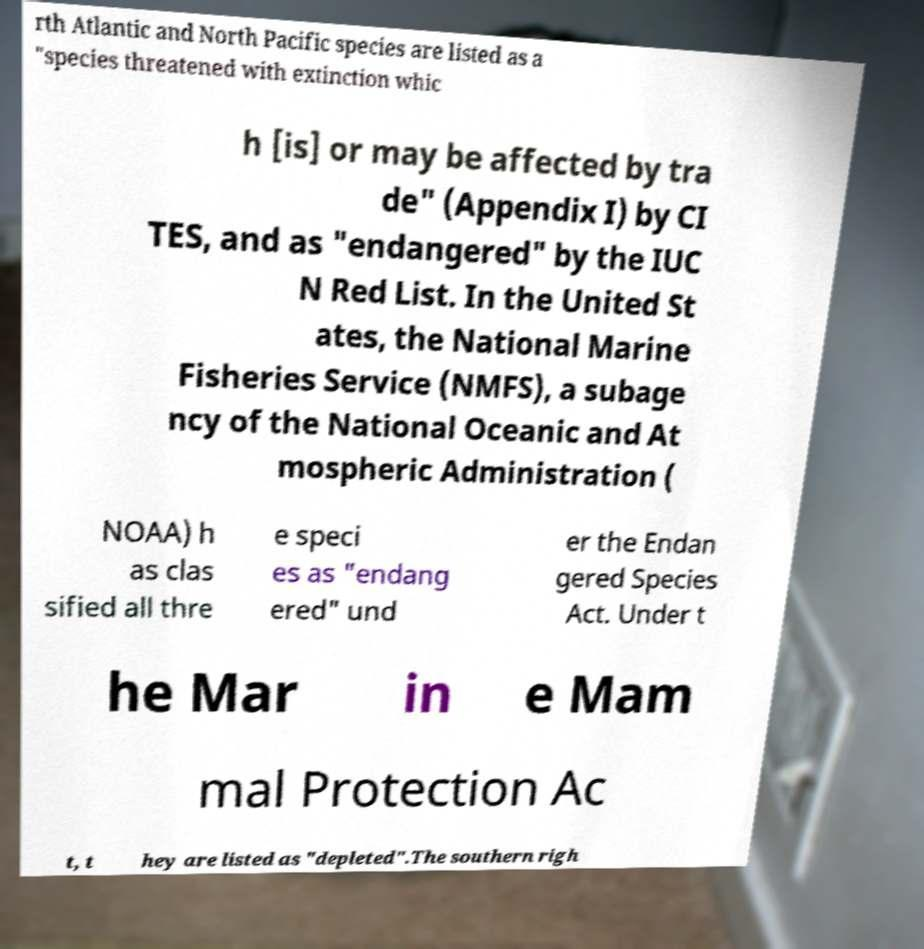What messages or text are displayed in this image? I need them in a readable, typed format. rth Atlantic and North Pacific species are listed as a "species threatened with extinction whic h [is] or may be affected by tra de" (Appendix I) by CI TES, and as "endangered" by the IUC N Red List. In the United St ates, the National Marine Fisheries Service (NMFS), a subage ncy of the National Oceanic and At mospheric Administration ( NOAA) h as clas sified all thre e speci es as "endang ered" und er the Endan gered Species Act. Under t he Mar in e Mam mal Protection Ac t, t hey are listed as "depleted".The southern righ 